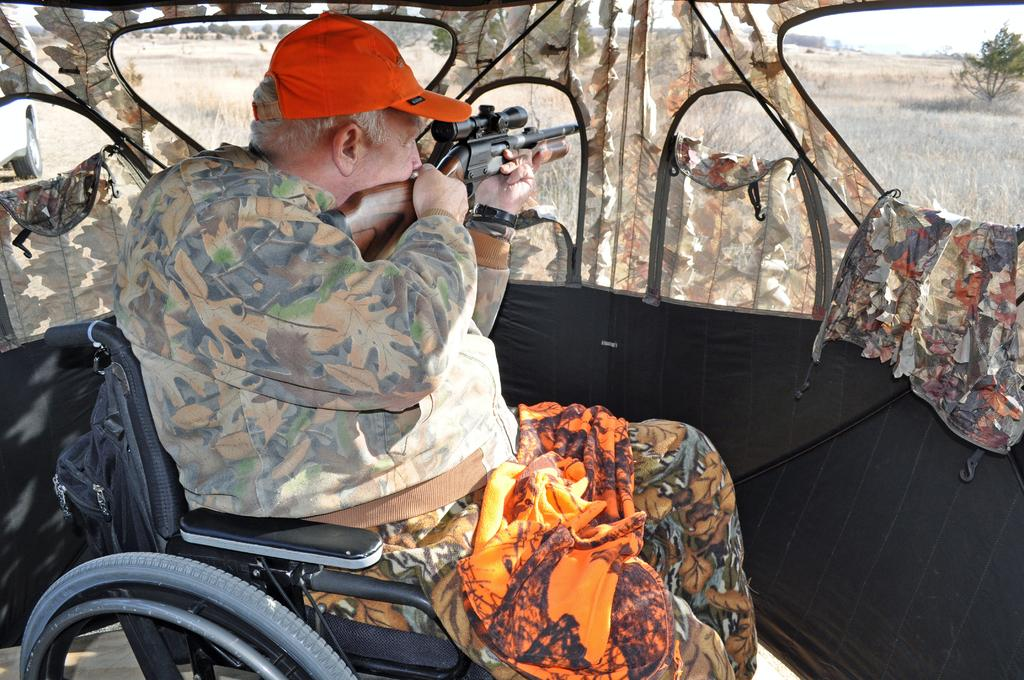What is inside the tent in the image? There is a person in the tent. What is the person in the tent using to support their mobility? The person is sitting on a wheelchair. What is the person holding in the image? The person is holding a gun. What can be seen behind the tent in the image? There is a vehicle behind the tent. What type of natural environment is visible in the image? Grass, trees, and the sky are visible in the image. What type of brass material is used to make the temper of the stitch in the image? There is no brass, temper, or stitch present in the image. 